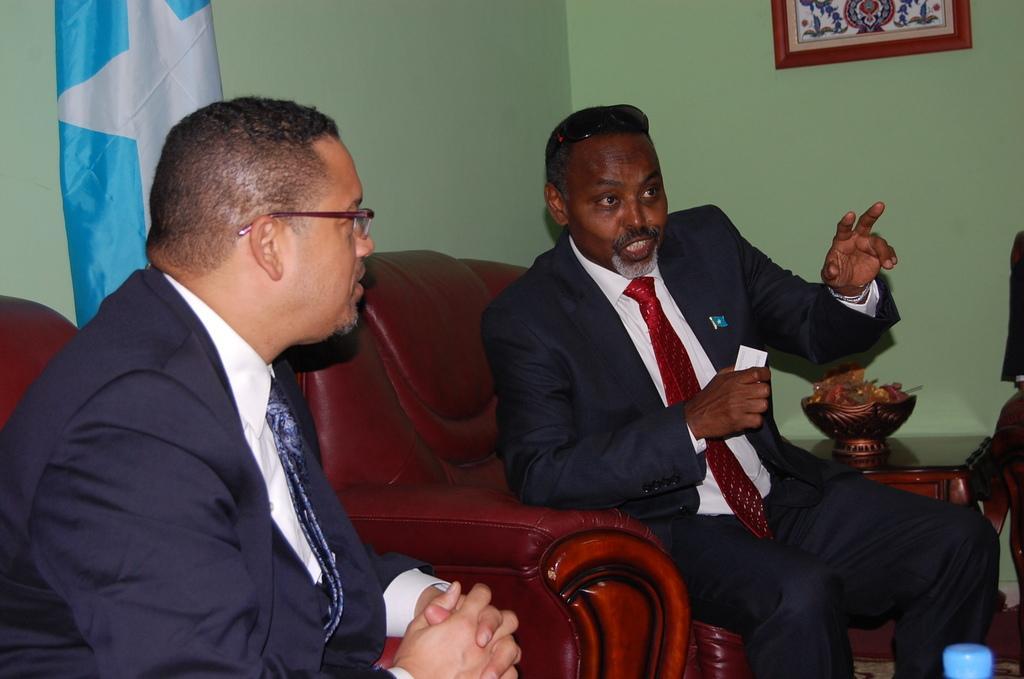Describe this image in one or two sentences. In this picture we can see two men wore blazers, ties and sitting on chairs and in front of them we can see a bottle and in the background we can see a table, basket with some objects in it, frame, walls, flag. 